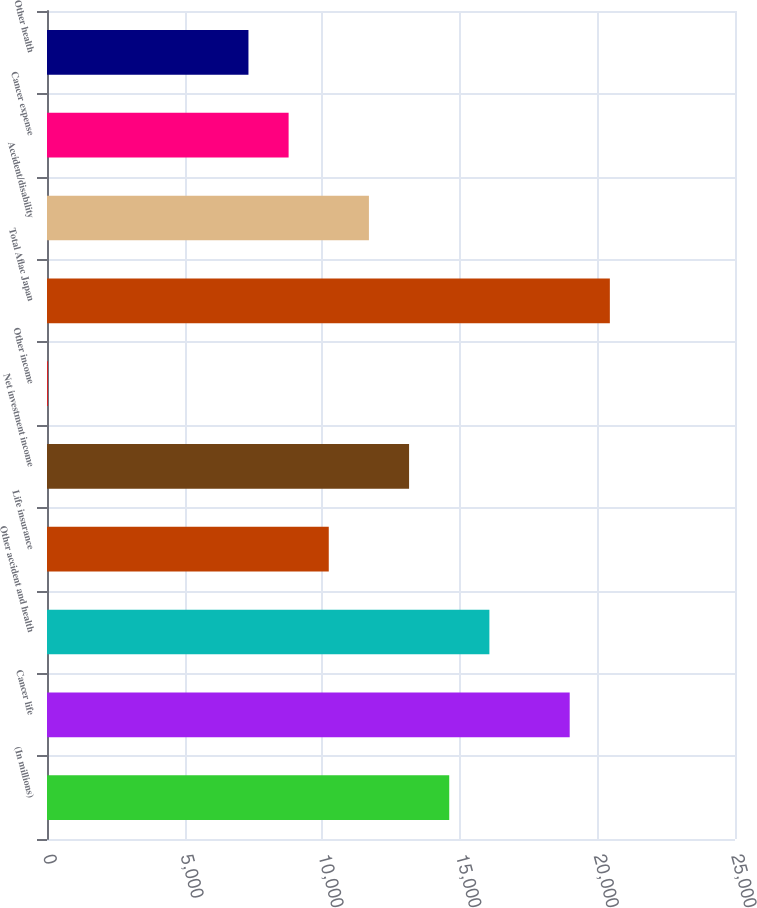<chart> <loc_0><loc_0><loc_500><loc_500><bar_chart><fcel>(In millions)<fcel>Cancer life<fcel>Other accident and health<fcel>Life insurance<fcel>Net investment income<fcel>Other income<fcel>Total Aflac Japan<fcel>Accident/disability<fcel>Cancer expense<fcel>Other health<nl><fcel>14616<fcel>18993.3<fcel>16075.1<fcel>10238.7<fcel>13156.9<fcel>25<fcel>20452.4<fcel>11697.8<fcel>8779.6<fcel>7320.5<nl></chart> 